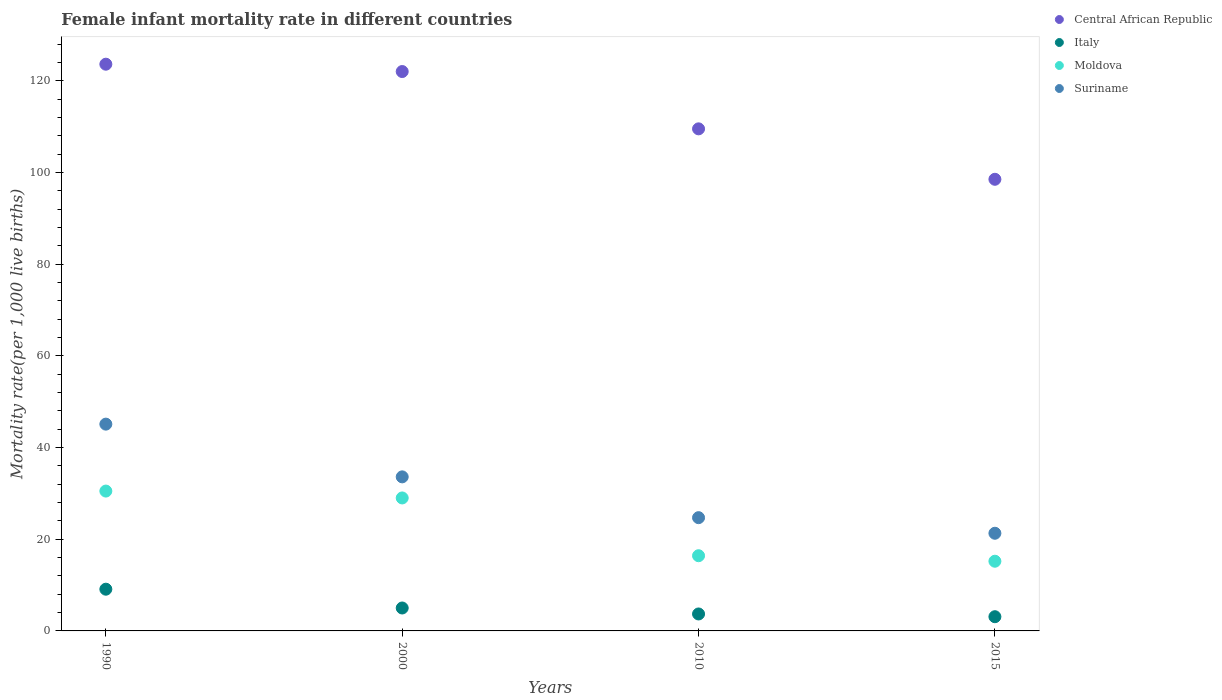What is the female infant mortality rate in Suriname in 2000?
Your response must be concise. 33.6. Across all years, what is the maximum female infant mortality rate in Central African Republic?
Ensure brevity in your answer.  123.6. Across all years, what is the minimum female infant mortality rate in Suriname?
Ensure brevity in your answer.  21.3. In which year was the female infant mortality rate in Suriname maximum?
Ensure brevity in your answer.  1990. In which year was the female infant mortality rate in Suriname minimum?
Your answer should be very brief. 2015. What is the total female infant mortality rate in Suriname in the graph?
Ensure brevity in your answer.  124.7. What is the difference between the female infant mortality rate in Central African Republic in 1990 and that in 2010?
Ensure brevity in your answer.  14.1. What is the difference between the female infant mortality rate in Central African Republic in 1990 and the female infant mortality rate in Moldova in 2010?
Make the answer very short. 107.2. What is the average female infant mortality rate in Italy per year?
Ensure brevity in your answer.  5.23. In the year 2015, what is the difference between the female infant mortality rate in Moldova and female infant mortality rate in Suriname?
Your answer should be compact. -6.1. In how many years, is the female infant mortality rate in Moldova greater than 8?
Provide a short and direct response. 4. What is the ratio of the female infant mortality rate in Central African Republic in 2000 to that in 2015?
Your answer should be compact. 1.24. Is the female infant mortality rate in Central African Republic in 2000 less than that in 2010?
Offer a very short reply. No. In how many years, is the female infant mortality rate in Moldova greater than the average female infant mortality rate in Moldova taken over all years?
Your response must be concise. 2. Does the female infant mortality rate in Moldova monotonically increase over the years?
Ensure brevity in your answer.  No. How many years are there in the graph?
Offer a terse response. 4. Does the graph contain grids?
Your response must be concise. No. Where does the legend appear in the graph?
Ensure brevity in your answer.  Top right. How many legend labels are there?
Offer a very short reply. 4. What is the title of the graph?
Ensure brevity in your answer.  Female infant mortality rate in different countries. What is the label or title of the X-axis?
Provide a succinct answer. Years. What is the label or title of the Y-axis?
Give a very brief answer. Mortality rate(per 1,0 live births). What is the Mortality rate(per 1,000 live births) in Central African Republic in 1990?
Offer a terse response. 123.6. What is the Mortality rate(per 1,000 live births) of Moldova in 1990?
Keep it short and to the point. 30.5. What is the Mortality rate(per 1,000 live births) in Suriname in 1990?
Your answer should be very brief. 45.1. What is the Mortality rate(per 1,000 live births) of Central African Republic in 2000?
Offer a terse response. 122. What is the Mortality rate(per 1,000 live births) in Italy in 2000?
Offer a very short reply. 5. What is the Mortality rate(per 1,000 live births) in Moldova in 2000?
Ensure brevity in your answer.  29. What is the Mortality rate(per 1,000 live births) of Suriname in 2000?
Provide a short and direct response. 33.6. What is the Mortality rate(per 1,000 live births) in Central African Republic in 2010?
Your answer should be compact. 109.5. What is the Mortality rate(per 1,000 live births) in Moldova in 2010?
Offer a very short reply. 16.4. What is the Mortality rate(per 1,000 live births) of Suriname in 2010?
Your response must be concise. 24.7. What is the Mortality rate(per 1,000 live births) of Central African Republic in 2015?
Your answer should be very brief. 98.5. What is the Mortality rate(per 1,000 live births) of Italy in 2015?
Provide a succinct answer. 3.1. What is the Mortality rate(per 1,000 live births) of Suriname in 2015?
Your answer should be compact. 21.3. Across all years, what is the maximum Mortality rate(per 1,000 live births) in Central African Republic?
Your response must be concise. 123.6. Across all years, what is the maximum Mortality rate(per 1,000 live births) in Italy?
Offer a terse response. 9.1. Across all years, what is the maximum Mortality rate(per 1,000 live births) in Moldova?
Ensure brevity in your answer.  30.5. Across all years, what is the maximum Mortality rate(per 1,000 live births) of Suriname?
Offer a very short reply. 45.1. Across all years, what is the minimum Mortality rate(per 1,000 live births) in Central African Republic?
Offer a very short reply. 98.5. Across all years, what is the minimum Mortality rate(per 1,000 live births) of Suriname?
Your answer should be very brief. 21.3. What is the total Mortality rate(per 1,000 live births) of Central African Republic in the graph?
Provide a short and direct response. 453.6. What is the total Mortality rate(per 1,000 live births) in Italy in the graph?
Provide a short and direct response. 20.9. What is the total Mortality rate(per 1,000 live births) of Moldova in the graph?
Make the answer very short. 91.1. What is the total Mortality rate(per 1,000 live births) of Suriname in the graph?
Ensure brevity in your answer.  124.7. What is the difference between the Mortality rate(per 1,000 live births) of Italy in 1990 and that in 2000?
Offer a very short reply. 4.1. What is the difference between the Mortality rate(per 1,000 live births) in Moldova in 1990 and that in 2000?
Keep it short and to the point. 1.5. What is the difference between the Mortality rate(per 1,000 live births) of Suriname in 1990 and that in 2000?
Your response must be concise. 11.5. What is the difference between the Mortality rate(per 1,000 live births) of Suriname in 1990 and that in 2010?
Keep it short and to the point. 20.4. What is the difference between the Mortality rate(per 1,000 live births) of Central African Republic in 1990 and that in 2015?
Ensure brevity in your answer.  25.1. What is the difference between the Mortality rate(per 1,000 live births) of Italy in 1990 and that in 2015?
Make the answer very short. 6. What is the difference between the Mortality rate(per 1,000 live births) of Moldova in 1990 and that in 2015?
Your answer should be very brief. 15.3. What is the difference between the Mortality rate(per 1,000 live births) in Suriname in 1990 and that in 2015?
Your answer should be very brief. 23.8. What is the difference between the Mortality rate(per 1,000 live births) of Moldova in 2000 and that in 2010?
Give a very brief answer. 12.6. What is the difference between the Mortality rate(per 1,000 live births) in Suriname in 2000 and that in 2010?
Keep it short and to the point. 8.9. What is the difference between the Mortality rate(per 1,000 live births) in Central African Republic in 1990 and the Mortality rate(per 1,000 live births) in Italy in 2000?
Make the answer very short. 118.6. What is the difference between the Mortality rate(per 1,000 live births) in Central African Republic in 1990 and the Mortality rate(per 1,000 live births) in Moldova in 2000?
Provide a succinct answer. 94.6. What is the difference between the Mortality rate(per 1,000 live births) in Central African Republic in 1990 and the Mortality rate(per 1,000 live births) in Suriname in 2000?
Your answer should be compact. 90. What is the difference between the Mortality rate(per 1,000 live births) in Italy in 1990 and the Mortality rate(per 1,000 live births) in Moldova in 2000?
Your response must be concise. -19.9. What is the difference between the Mortality rate(per 1,000 live births) in Italy in 1990 and the Mortality rate(per 1,000 live births) in Suriname in 2000?
Offer a very short reply. -24.5. What is the difference between the Mortality rate(per 1,000 live births) of Central African Republic in 1990 and the Mortality rate(per 1,000 live births) of Italy in 2010?
Make the answer very short. 119.9. What is the difference between the Mortality rate(per 1,000 live births) of Central African Republic in 1990 and the Mortality rate(per 1,000 live births) of Moldova in 2010?
Ensure brevity in your answer.  107.2. What is the difference between the Mortality rate(per 1,000 live births) in Central African Republic in 1990 and the Mortality rate(per 1,000 live births) in Suriname in 2010?
Keep it short and to the point. 98.9. What is the difference between the Mortality rate(per 1,000 live births) of Italy in 1990 and the Mortality rate(per 1,000 live births) of Suriname in 2010?
Give a very brief answer. -15.6. What is the difference between the Mortality rate(per 1,000 live births) of Moldova in 1990 and the Mortality rate(per 1,000 live births) of Suriname in 2010?
Keep it short and to the point. 5.8. What is the difference between the Mortality rate(per 1,000 live births) in Central African Republic in 1990 and the Mortality rate(per 1,000 live births) in Italy in 2015?
Offer a very short reply. 120.5. What is the difference between the Mortality rate(per 1,000 live births) of Central African Republic in 1990 and the Mortality rate(per 1,000 live births) of Moldova in 2015?
Keep it short and to the point. 108.4. What is the difference between the Mortality rate(per 1,000 live births) in Central African Republic in 1990 and the Mortality rate(per 1,000 live births) in Suriname in 2015?
Offer a very short reply. 102.3. What is the difference between the Mortality rate(per 1,000 live births) in Italy in 1990 and the Mortality rate(per 1,000 live births) in Moldova in 2015?
Your answer should be compact. -6.1. What is the difference between the Mortality rate(per 1,000 live births) in Italy in 1990 and the Mortality rate(per 1,000 live births) in Suriname in 2015?
Offer a very short reply. -12.2. What is the difference between the Mortality rate(per 1,000 live births) of Central African Republic in 2000 and the Mortality rate(per 1,000 live births) of Italy in 2010?
Your answer should be compact. 118.3. What is the difference between the Mortality rate(per 1,000 live births) of Central African Republic in 2000 and the Mortality rate(per 1,000 live births) of Moldova in 2010?
Give a very brief answer. 105.6. What is the difference between the Mortality rate(per 1,000 live births) in Central African Republic in 2000 and the Mortality rate(per 1,000 live births) in Suriname in 2010?
Offer a very short reply. 97.3. What is the difference between the Mortality rate(per 1,000 live births) in Italy in 2000 and the Mortality rate(per 1,000 live births) in Suriname in 2010?
Your answer should be compact. -19.7. What is the difference between the Mortality rate(per 1,000 live births) of Central African Republic in 2000 and the Mortality rate(per 1,000 live births) of Italy in 2015?
Give a very brief answer. 118.9. What is the difference between the Mortality rate(per 1,000 live births) in Central African Republic in 2000 and the Mortality rate(per 1,000 live births) in Moldova in 2015?
Provide a succinct answer. 106.8. What is the difference between the Mortality rate(per 1,000 live births) of Central African Republic in 2000 and the Mortality rate(per 1,000 live births) of Suriname in 2015?
Your answer should be compact. 100.7. What is the difference between the Mortality rate(per 1,000 live births) in Italy in 2000 and the Mortality rate(per 1,000 live births) in Moldova in 2015?
Provide a short and direct response. -10.2. What is the difference between the Mortality rate(per 1,000 live births) in Italy in 2000 and the Mortality rate(per 1,000 live births) in Suriname in 2015?
Make the answer very short. -16.3. What is the difference between the Mortality rate(per 1,000 live births) in Moldova in 2000 and the Mortality rate(per 1,000 live births) in Suriname in 2015?
Make the answer very short. 7.7. What is the difference between the Mortality rate(per 1,000 live births) of Central African Republic in 2010 and the Mortality rate(per 1,000 live births) of Italy in 2015?
Make the answer very short. 106.4. What is the difference between the Mortality rate(per 1,000 live births) in Central African Republic in 2010 and the Mortality rate(per 1,000 live births) in Moldova in 2015?
Ensure brevity in your answer.  94.3. What is the difference between the Mortality rate(per 1,000 live births) of Central African Republic in 2010 and the Mortality rate(per 1,000 live births) of Suriname in 2015?
Your answer should be compact. 88.2. What is the difference between the Mortality rate(per 1,000 live births) of Italy in 2010 and the Mortality rate(per 1,000 live births) of Suriname in 2015?
Provide a short and direct response. -17.6. What is the average Mortality rate(per 1,000 live births) in Central African Republic per year?
Provide a short and direct response. 113.4. What is the average Mortality rate(per 1,000 live births) in Italy per year?
Provide a short and direct response. 5.22. What is the average Mortality rate(per 1,000 live births) in Moldova per year?
Ensure brevity in your answer.  22.77. What is the average Mortality rate(per 1,000 live births) of Suriname per year?
Your answer should be compact. 31.18. In the year 1990, what is the difference between the Mortality rate(per 1,000 live births) of Central African Republic and Mortality rate(per 1,000 live births) of Italy?
Provide a succinct answer. 114.5. In the year 1990, what is the difference between the Mortality rate(per 1,000 live births) in Central African Republic and Mortality rate(per 1,000 live births) in Moldova?
Your response must be concise. 93.1. In the year 1990, what is the difference between the Mortality rate(per 1,000 live births) in Central African Republic and Mortality rate(per 1,000 live births) in Suriname?
Give a very brief answer. 78.5. In the year 1990, what is the difference between the Mortality rate(per 1,000 live births) of Italy and Mortality rate(per 1,000 live births) of Moldova?
Provide a succinct answer. -21.4. In the year 1990, what is the difference between the Mortality rate(per 1,000 live births) in Italy and Mortality rate(per 1,000 live births) in Suriname?
Keep it short and to the point. -36. In the year 1990, what is the difference between the Mortality rate(per 1,000 live births) in Moldova and Mortality rate(per 1,000 live births) in Suriname?
Ensure brevity in your answer.  -14.6. In the year 2000, what is the difference between the Mortality rate(per 1,000 live births) of Central African Republic and Mortality rate(per 1,000 live births) of Italy?
Keep it short and to the point. 117. In the year 2000, what is the difference between the Mortality rate(per 1,000 live births) of Central African Republic and Mortality rate(per 1,000 live births) of Moldova?
Provide a succinct answer. 93. In the year 2000, what is the difference between the Mortality rate(per 1,000 live births) in Central African Republic and Mortality rate(per 1,000 live births) in Suriname?
Your answer should be very brief. 88.4. In the year 2000, what is the difference between the Mortality rate(per 1,000 live births) in Italy and Mortality rate(per 1,000 live births) in Suriname?
Keep it short and to the point. -28.6. In the year 2010, what is the difference between the Mortality rate(per 1,000 live births) of Central African Republic and Mortality rate(per 1,000 live births) of Italy?
Ensure brevity in your answer.  105.8. In the year 2010, what is the difference between the Mortality rate(per 1,000 live births) in Central African Republic and Mortality rate(per 1,000 live births) in Moldova?
Ensure brevity in your answer.  93.1. In the year 2010, what is the difference between the Mortality rate(per 1,000 live births) in Central African Republic and Mortality rate(per 1,000 live births) in Suriname?
Offer a very short reply. 84.8. In the year 2015, what is the difference between the Mortality rate(per 1,000 live births) of Central African Republic and Mortality rate(per 1,000 live births) of Italy?
Make the answer very short. 95.4. In the year 2015, what is the difference between the Mortality rate(per 1,000 live births) in Central African Republic and Mortality rate(per 1,000 live births) in Moldova?
Your response must be concise. 83.3. In the year 2015, what is the difference between the Mortality rate(per 1,000 live births) in Central African Republic and Mortality rate(per 1,000 live births) in Suriname?
Your response must be concise. 77.2. In the year 2015, what is the difference between the Mortality rate(per 1,000 live births) in Italy and Mortality rate(per 1,000 live births) in Moldova?
Offer a terse response. -12.1. In the year 2015, what is the difference between the Mortality rate(per 1,000 live births) of Italy and Mortality rate(per 1,000 live births) of Suriname?
Make the answer very short. -18.2. What is the ratio of the Mortality rate(per 1,000 live births) in Central African Republic in 1990 to that in 2000?
Make the answer very short. 1.01. What is the ratio of the Mortality rate(per 1,000 live births) in Italy in 1990 to that in 2000?
Your answer should be compact. 1.82. What is the ratio of the Mortality rate(per 1,000 live births) of Moldova in 1990 to that in 2000?
Offer a very short reply. 1.05. What is the ratio of the Mortality rate(per 1,000 live births) of Suriname in 1990 to that in 2000?
Ensure brevity in your answer.  1.34. What is the ratio of the Mortality rate(per 1,000 live births) of Central African Republic in 1990 to that in 2010?
Give a very brief answer. 1.13. What is the ratio of the Mortality rate(per 1,000 live births) of Italy in 1990 to that in 2010?
Keep it short and to the point. 2.46. What is the ratio of the Mortality rate(per 1,000 live births) of Moldova in 1990 to that in 2010?
Your answer should be very brief. 1.86. What is the ratio of the Mortality rate(per 1,000 live births) in Suriname in 1990 to that in 2010?
Your answer should be very brief. 1.83. What is the ratio of the Mortality rate(per 1,000 live births) in Central African Republic in 1990 to that in 2015?
Keep it short and to the point. 1.25. What is the ratio of the Mortality rate(per 1,000 live births) in Italy in 1990 to that in 2015?
Offer a terse response. 2.94. What is the ratio of the Mortality rate(per 1,000 live births) in Moldova in 1990 to that in 2015?
Provide a succinct answer. 2.01. What is the ratio of the Mortality rate(per 1,000 live births) of Suriname in 1990 to that in 2015?
Offer a terse response. 2.12. What is the ratio of the Mortality rate(per 1,000 live births) of Central African Republic in 2000 to that in 2010?
Offer a very short reply. 1.11. What is the ratio of the Mortality rate(per 1,000 live births) of Italy in 2000 to that in 2010?
Provide a succinct answer. 1.35. What is the ratio of the Mortality rate(per 1,000 live births) of Moldova in 2000 to that in 2010?
Ensure brevity in your answer.  1.77. What is the ratio of the Mortality rate(per 1,000 live births) in Suriname in 2000 to that in 2010?
Your answer should be compact. 1.36. What is the ratio of the Mortality rate(per 1,000 live births) in Central African Republic in 2000 to that in 2015?
Give a very brief answer. 1.24. What is the ratio of the Mortality rate(per 1,000 live births) of Italy in 2000 to that in 2015?
Ensure brevity in your answer.  1.61. What is the ratio of the Mortality rate(per 1,000 live births) of Moldova in 2000 to that in 2015?
Your answer should be compact. 1.91. What is the ratio of the Mortality rate(per 1,000 live births) of Suriname in 2000 to that in 2015?
Your answer should be compact. 1.58. What is the ratio of the Mortality rate(per 1,000 live births) in Central African Republic in 2010 to that in 2015?
Your answer should be very brief. 1.11. What is the ratio of the Mortality rate(per 1,000 live births) of Italy in 2010 to that in 2015?
Ensure brevity in your answer.  1.19. What is the ratio of the Mortality rate(per 1,000 live births) in Moldova in 2010 to that in 2015?
Your answer should be very brief. 1.08. What is the ratio of the Mortality rate(per 1,000 live births) in Suriname in 2010 to that in 2015?
Provide a succinct answer. 1.16. What is the difference between the highest and the second highest Mortality rate(per 1,000 live births) in Central African Republic?
Provide a succinct answer. 1.6. What is the difference between the highest and the second highest Mortality rate(per 1,000 live births) in Italy?
Make the answer very short. 4.1. What is the difference between the highest and the second highest Mortality rate(per 1,000 live births) in Suriname?
Offer a very short reply. 11.5. What is the difference between the highest and the lowest Mortality rate(per 1,000 live births) of Central African Republic?
Offer a terse response. 25.1. What is the difference between the highest and the lowest Mortality rate(per 1,000 live births) of Italy?
Your response must be concise. 6. What is the difference between the highest and the lowest Mortality rate(per 1,000 live births) in Moldova?
Offer a terse response. 15.3. What is the difference between the highest and the lowest Mortality rate(per 1,000 live births) of Suriname?
Provide a short and direct response. 23.8. 